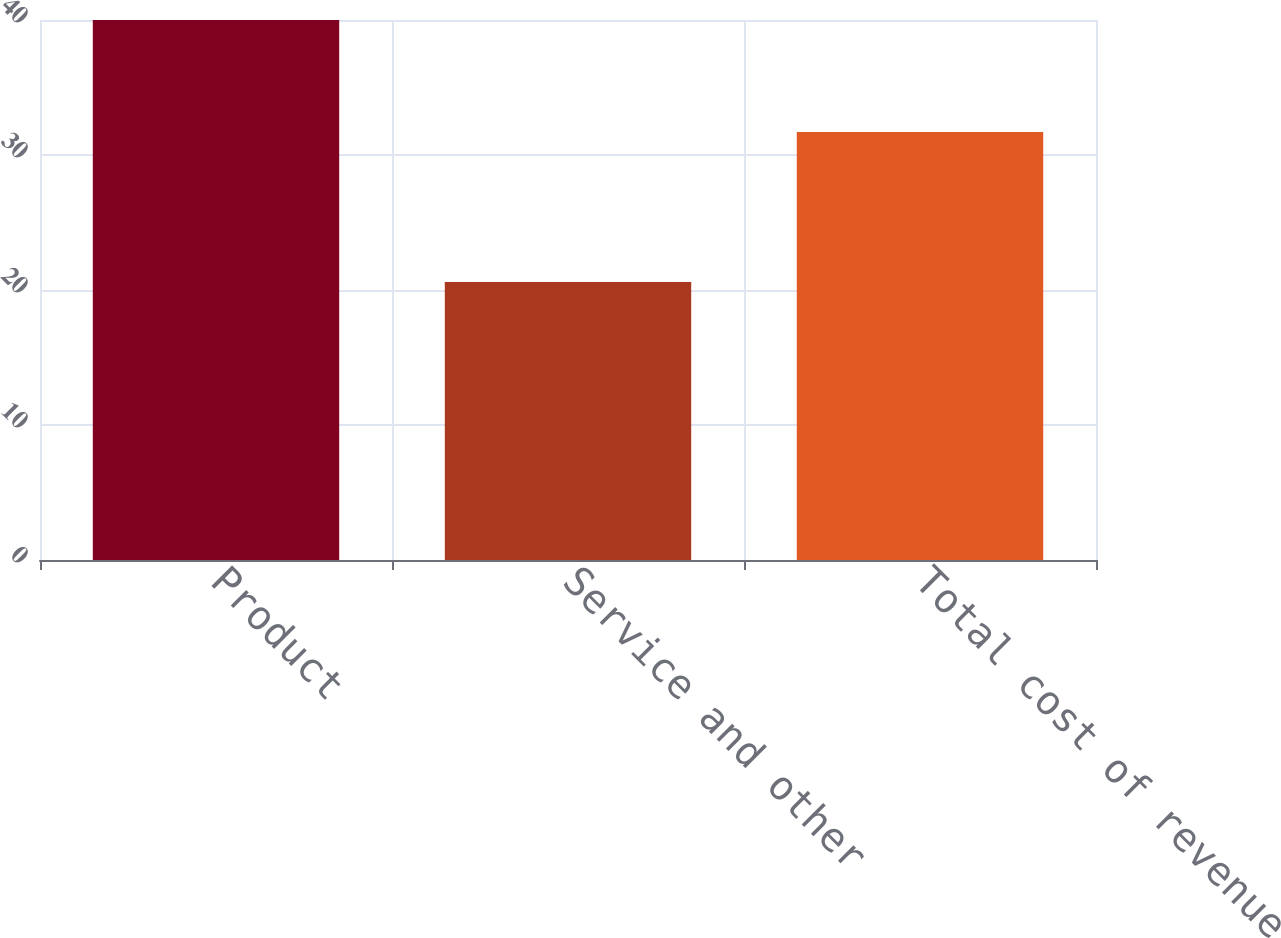Convert chart. <chart><loc_0><loc_0><loc_500><loc_500><bar_chart><fcel>Product<fcel>Service and other<fcel>Total cost of revenue<nl><fcel>40<fcel>20.6<fcel>31.7<nl></chart> 